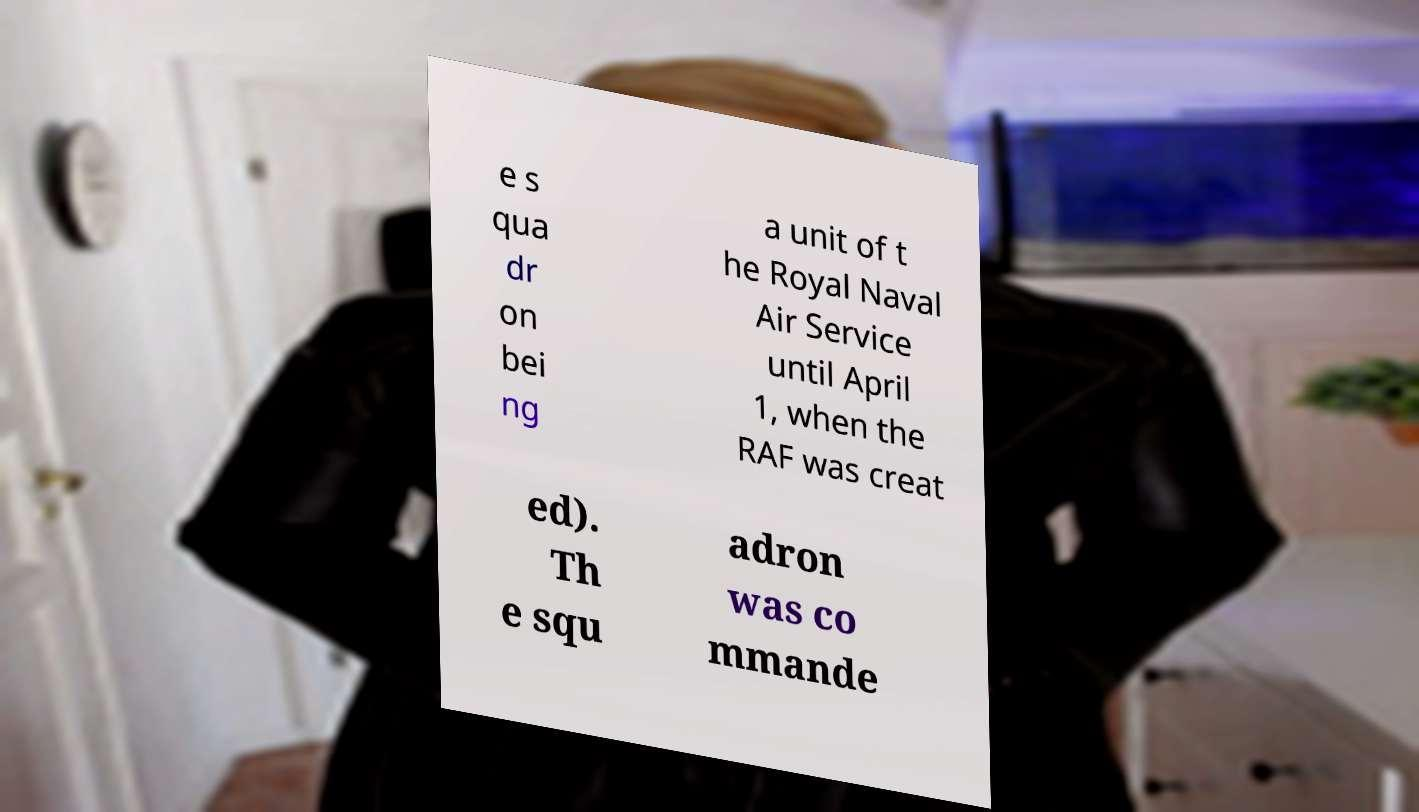What messages or text are displayed in this image? I need them in a readable, typed format. e s qua dr on bei ng a unit of t he Royal Naval Air Service until April 1, when the RAF was creat ed). Th e squ adron was co mmande 